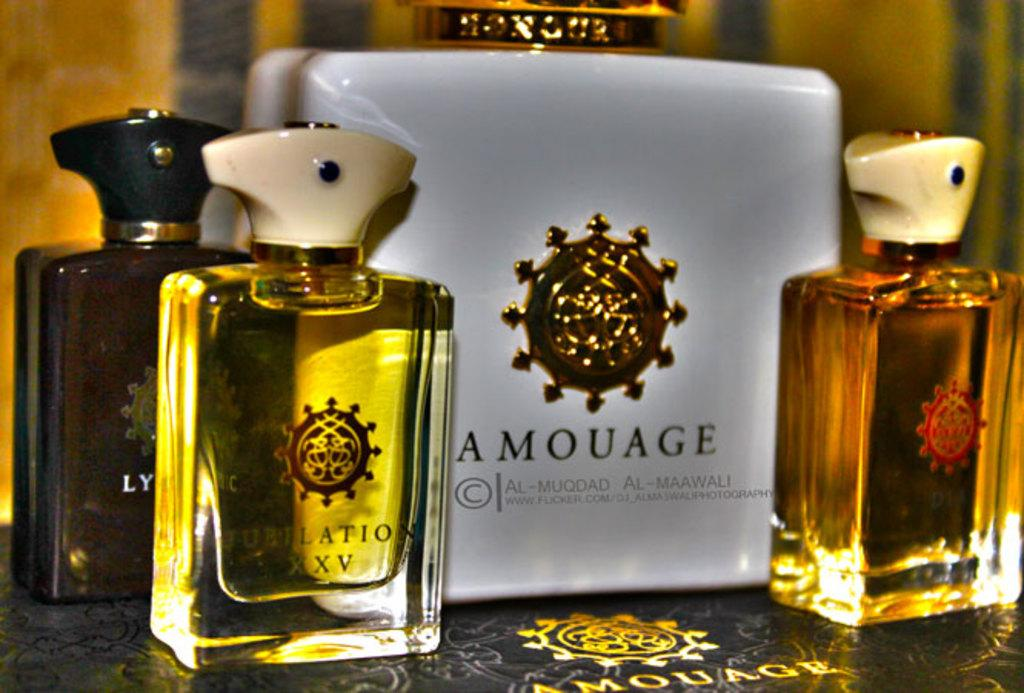<image>
Summarize the visual content of the image. Amouage makes several different items, including Jubilation XXV 